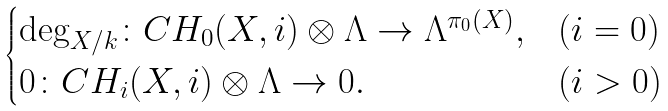<formula> <loc_0><loc_0><loc_500><loc_500>\begin{cases} \deg _ { X / k } \colon C H _ { 0 } ( X , i ) \otimes \Lambda \to \Lambda ^ { \pi _ { 0 } ( X ) } , & ( i = 0 ) \\ 0 \colon C H _ { i } ( X , i ) \otimes \Lambda \to 0 . & ( i > 0 ) \end{cases}</formula> 